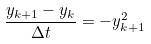<formula> <loc_0><loc_0><loc_500><loc_500>\frac { y _ { k + 1 } - y _ { k } } { \Delta t } = - y _ { k + 1 } ^ { 2 }</formula> 